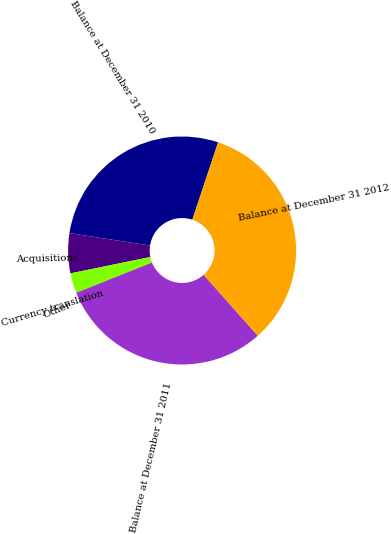Convert chart to OTSL. <chart><loc_0><loc_0><loc_500><loc_500><pie_chart><fcel>Balance at December 31 2010<fcel>Acquisitions<fcel>Currency translation<fcel>Other<fcel>Balance at December 31 2011<fcel>Balance at December 31 2012<nl><fcel>27.67%<fcel>5.66%<fcel>2.83%<fcel>0.01%<fcel>30.5%<fcel>33.33%<nl></chart> 